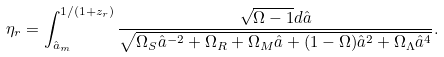<formula> <loc_0><loc_0><loc_500><loc_500>\eta _ { r } = \int _ { \hat { a } _ { m } } ^ { 1 / ( 1 + z _ { r } ) } \frac { \sqrt { \Omega - 1 } d \hat { a } } { \sqrt { \Omega _ { S } \hat { a } ^ { - 2 } + \Omega _ { R } + \Omega _ { M } \hat { a } + ( 1 - \Omega ) \hat { a } ^ { 2 } + \Omega _ { \Lambda } \hat { a } ^ { 4 } } } .</formula> 